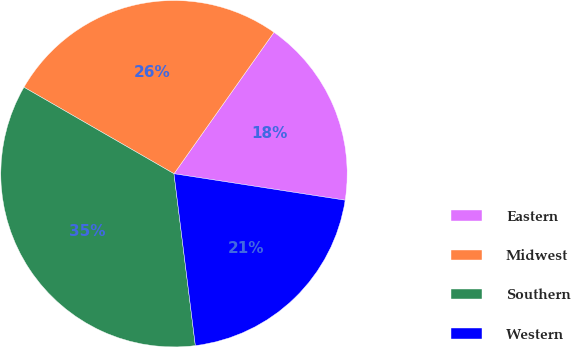<chart> <loc_0><loc_0><loc_500><loc_500><pie_chart><fcel>Eastern<fcel>Midwest<fcel>Southern<fcel>Western<nl><fcel>17.65%<fcel>26.47%<fcel>35.29%<fcel>20.59%<nl></chart> 